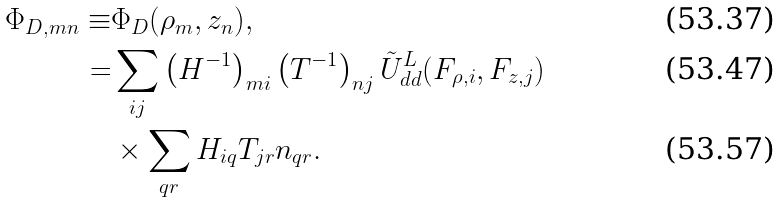<formula> <loc_0><loc_0><loc_500><loc_500>\Phi _ { D , m n } \equiv & \Phi _ { D } ( \rho _ { m } , z _ { n } ) , \\ = & \sum _ { i j } \left ( H ^ { - 1 } \right ) _ { m i } \left ( T ^ { - 1 } \right ) _ { n j } \tilde { U } ^ { L } _ { d d } ( F _ { \rho , i } , F _ { z , j } ) \\ & \times \sum _ { q r } H _ { i q } T _ { j r } n _ { q r } .</formula> 